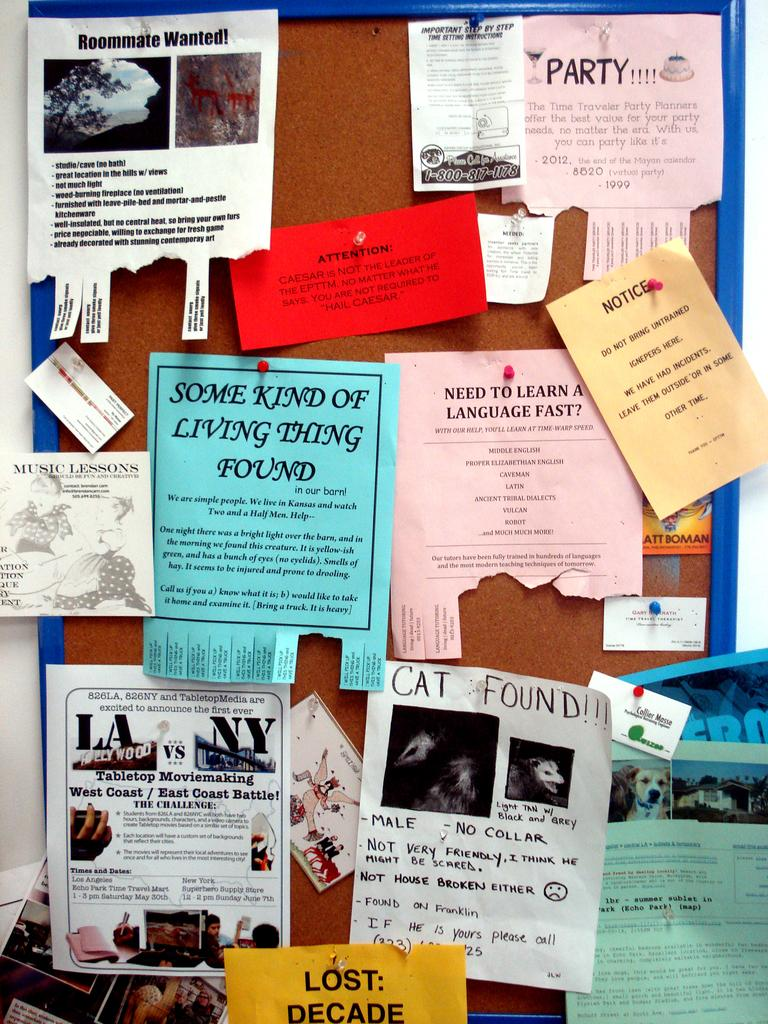<image>
Summarize the visual content of the image. A bulletin board with many things posted on it and one flyer says Some Kind Of Living Thing Found. 